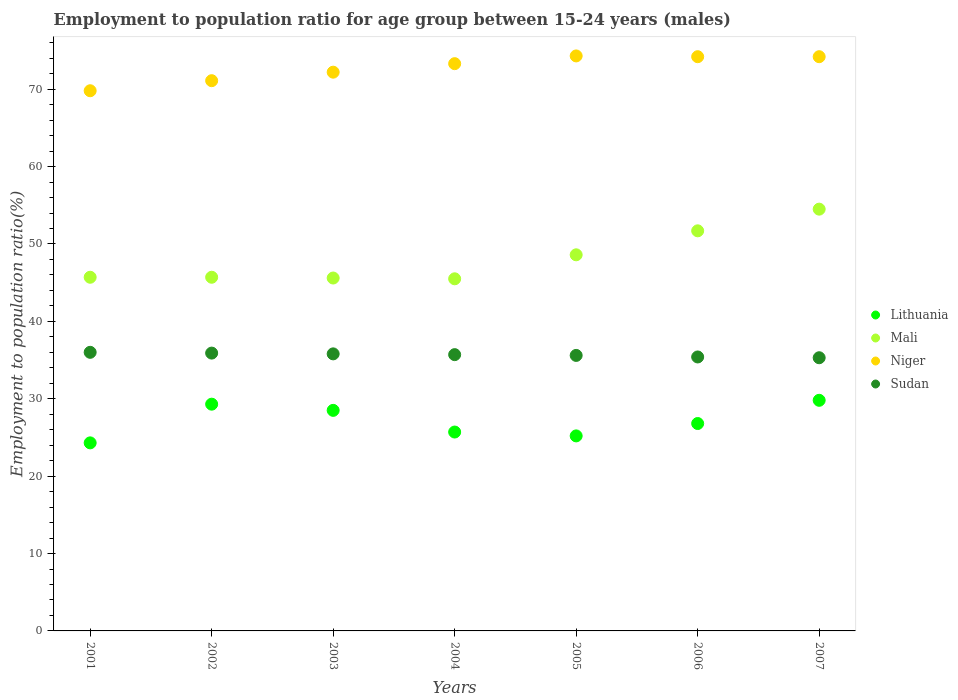What is the employment to population ratio in Niger in 2002?
Provide a short and direct response. 71.1. Across all years, what is the maximum employment to population ratio in Niger?
Ensure brevity in your answer.  74.3. Across all years, what is the minimum employment to population ratio in Sudan?
Give a very brief answer. 35.3. What is the total employment to population ratio in Niger in the graph?
Offer a terse response. 509.1. What is the difference between the employment to population ratio in Lithuania in 2003 and that in 2007?
Your response must be concise. -1.3. What is the difference between the employment to population ratio in Mali in 2006 and the employment to population ratio in Sudan in 2005?
Give a very brief answer. 16.1. What is the average employment to population ratio in Niger per year?
Provide a succinct answer. 72.73. In the year 2006, what is the difference between the employment to population ratio in Niger and employment to population ratio in Mali?
Provide a short and direct response. 22.5. What is the ratio of the employment to population ratio in Niger in 2002 to that in 2006?
Ensure brevity in your answer.  0.96. Is the employment to population ratio in Niger in 2004 less than that in 2007?
Offer a very short reply. Yes. What is the difference between the highest and the second highest employment to population ratio in Sudan?
Make the answer very short. 0.1. In how many years, is the employment to population ratio in Sudan greater than the average employment to population ratio in Sudan taken over all years?
Your answer should be very brief. 4. Is it the case that in every year, the sum of the employment to population ratio in Mali and employment to population ratio in Niger  is greater than the sum of employment to population ratio in Sudan and employment to population ratio in Lithuania?
Your response must be concise. Yes. Does the employment to population ratio in Mali monotonically increase over the years?
Your answer should be very brief. No. What is the difference between two consecutive major ticks on the Y-axis?
Give a very brief answer. 10. Are the values on the major ticks of Y-axis written in scientific E-notation?
Provide a succinct answer. No. Does the graph contain any zero values?
Provide a short and direct response. No. How many legend labels are there?
Offer a terse response. 4. How are the legend labels stacked?
Ensure brevity in your answer.  Vertical. What is the title of the graph?
Give a very brief answer. Employment to population ratio for age group between 15-24 years (males). Does "Niger" appear as one of the legend labels in the graph?
Give a very brief answer. Yes. What is the Employment to population ratio(%) in Lithuania in 2001?
Offer a very short reply. 24.3. What is the Employment to population ratio(%) in Mali in 2001?
Ensure brevity in your answer.  45.7. What is the Employment to population ratio(%) in Niger in 2001?
Your answer should be compact. 69.8. What is the Employment to population ratio(%) of Lithuania in 2002?
Provide a short and direct response. 29.3. What is the Employment to population ratio(%) in Mali in 2002?
Make the answer very short. 45.7. What is the Employment to population ratio(%) in Niger in 2002?
Offer a terse response. 71.1. What is the Employment to population ratio(%) in Sudan in 2002?
Keep it short and to the point. 35.9. What is the Employment to population ratio(%) in Mali in 2003?
Your response must be concise. 45.6. What is the Employment to population ratio(%) in Niger in 2003?
Make the answer very short. 72.2. What is the Employment to population ratio(%) of Sudan in 2003?
Your response must be concise. 35.8. What is the Employment to population ratio(%) of Lithuania in 2004?
Your answer should be compact. 25.7. What is the Employment to population ratio(%) in Mali in 2004?
Offer a very short reply. 45.5. What is the Employment to population ratio(%) in Niger in 2004?
Keep it short and to the point. 73.3. What is the Employment to population ratio(%) in Sudan in 2004?
Make the answer very short. 35.7. What is the Employment to population ratio(%) in Lithuania in 2005?
Ensure brevity in your answer.  25.2. What is the Employment to population ratio(%) of Mali in 2005?
Ensure brevity in your answer.  48.6. What is the Employment to population ratio(%) in Niger in 2005?
Provide a short and direct response. 74.3. What is the Employment to population ratio(%) in Sudan in 2005?
Your answer should be very brief. 35.6. What is the Employment to population ratio(%) of Lithuania in 2006?
Provide a short and direct response. 26.8. What is the Employment to population ratio(%) in Mali in 2006?
Provide a short and direct response. 51.7. What is the Employment to population ratio(%) of Niger in 2006?
Keep it short and to the point. 74.2. What is the Employment to population ratio(%) in Sudan in 2006?
Provide a short and direct response. 35.4. What is the Employment to population ratio(%) of Lithuania in 2007?
Ensure brevity in your answer.  29.8. What is the Employment to population ratio(%) of Mali in 2007?
Keep it short and to the point. 54.5. What is the Employment to population ratio(%) in Niger in 2007?
Ensure brevity in your answer.  74.2. What is the Employment to population ratio(%) of Sudan in 2007?
Give a very brief answer. 35.3. Across all years, what is the maximum Employment to population ratio(%) in Lithuania?
Provide a short and direct response. 29.8. Across all years, what is the maximum Employment to population ratio(%) in Mali?
Your answer should be compact. 54.5. Across all years, what is the maximum Employment to population ratio(%) in Niger?
Ensure brevity in your answer.  74.3. Across all years, what is the minimum Employment to population ratio(%) in Lithuania?
Make the answer very short. 24.3. Across all years, what is the minimum Employment to population ratio(%) in Mali?
Your answer should be compact. 45.5. Across all years, what is the minimum Employment to population ratio(%) of Niger?
Offer a very short reply. 69.8. Across all years, what is the minimum Employment to population ratio(%) of Sudan?
Keep it short and to the point. 35.3. What is the total Employment to population ratio(%) of Lithuania in the graph?
Your answer should be compact. 189.6. What is the total Employment to population ratio(%) of Mali in the graph?
Your answer should be compact. 337.3. What is the total Employment to population ratio(%) of Niger in the graph?
Give a very brief answer. 509.1. What is the total Employment to population ratio(%) in Sudan in the graph?
Offer a terse response. 249.7. What is the difference between the Employment to population ratio(%) in Lithuania in 2001 and that in 2002?
Offer a terse response. -5. What is the difference between the Employment to population ratio(%) in Sudan in 2001 and that in 2002?
Your answer should be compact. 0.1. What is the difference between the Employment to population ratio(%) of Lithuania in 2001 and that in 2003?
Ensure brevity in your answer.  -4.2. What is the difference between the Employment to population ratio(%) in Mali in 2001 and that in 2003?
Provide a succinct answer. 0.1. What is the difference between the Employment to population ratio(%) in Niger in 2001 and that in 2003?
Your answer should be compact. -2.4. What is the difference between the Employment to population ratio(%) of Sudan in 2001 and that in 2003?
Offer a terse response. 0.2. What is the difference between the Employment to population ratio(%) in Lithuania in 2001 and that in 2004?
Offer a very short reply. -1.4. What is the difference between the Employment to population ratio(%) in Niger in 2001 and that in 2004?
Make the answer very short. -3.5. What is the difference between the Employment to population ratio(%) in Sudan in 2001 and that in 2004?
Make the answer very short. 0.3. What is the difference between the Employment to population ratio(%) in Niger in 2001 and that in 2005?
Keep it short and to the point. -4.5. What is the difference between the Employment to population ratio(%) of Sudan in 2001 and that in 2005?
Make the answer very short. 0.4. What is the difference between the Employment to population ratio(%) of Lithuania in 2001 and that in 2006?
Your answer should be very brief. -2.5. What is the difference between the Employment to population ratio(%) of Mali in 2001 and that in 2006?
Your answer should be compact. -6. What is the difference between the Employment to population ratio(%) of Sudan in 2001 and that in 2006?
Offer a terse response. 0.6. What is the difference between the Employment to population ratio(%) in Mali in 2001 and that in 2007?
Your answer should be compact. -8.8. What is the difference between the Employment to population ratio(%) in Niger in 2001 and that in 2007?
Offer a very short reply. -4.4. What is the difference between the Employment to population ratio(%) of Sudan in 2002 and that in 2003?
Provide a short and direct response. 0.1. What is the difference between the Employment to population ratio(%) of Sudan in 2002 and that in 2004?
Your response must be concise. 0.2. What is the difference between the Employment to population ratio(%) of Mali in 2002 and that in 2005?
Your answer should be very brief. -2.9. What is the difference between the Employment to population ratio(%) in Sudan in 2002 and that in 2005?
Your answer should be compact. 0.3. What is the difference between the Employment to population ratio(%) of Mali in 2002 and that in 2006?
Your answer should be very brief. -6. What is the difference between the Employment to population ratio(%) of Niger in 2002 and that in 2006?
Give a very brief answer. -3.1. What is the difference between the Employment to population ratio(%) in Mali in 2002 and that in 2007?
Ensure brevity in your answer.  -8.8. What is the difference between the Employment to population ratio(%) in Lithuania in 2003 and that in 2004?
Ensure brevity in your answer.  2.8. What is the difference between the Employment to population ratio(%) of Mali in 2003 and that in 2004?
Ensure brevity in your answer.  0.1. What is the difference between the Employment to population ratio(%) of Niger in 2003 and that in 2004?
Make the answer very short. -1.1. What is the difference between the Employment to population ratio(%) in Lithuania in 2003 and that in 2005?
Ensure brevity in your answer.  3.3. What is the difference between the Employment to population ratio(%) in Mali in 2003 and that in 2005?
Keep it short and to the point. -3. What is the difference between the Employment to population ratio(%) of Sudan in 2003 and that in 2005?
Keep it short and to the point. 0.2. What is the difference between the Employment to population ratio(%) of Mali in 2003 and that in 2006?
Your answer should be very brief. -6.1. What is the difference between the Employment to population ratio(%) of Niger in 2003 and that in 2006?
Provide a short and direct response. -2. What is the difference between the Employment to population ratio(%) in Lithuania in 2003 and that in 2007?
Offer a terse response. -1.3. What is the difference between the Employment to population ratio(%) in Mali in 2003 and that in 2007?
Provide a succinct answer. -8.9. What is the difference between the Employment to population ratio(%) of Niger in 2003 and that in 2007?
Ensure brevity in your answer.  -2. What is the difference between the Employment to population ratio(%) in Sudan in 2003 and that in 2007?
Give a very brief answer. 0.5. What is the difference between the Employment to population ratio(%) of Lithuania in 2004 and that in 2005?
Provide a succinct answer. 0.5. What is the difference between the Employment to population ratio(%) in Mali in 2004 and that in 2005?
Keep it short and to the point. -3.1. What is the difference between the Employment to population ratio(%) in Lithuania in 2004 and that in 2006?
Your response must be concise. -1.1. What is the difference between the Employment to population ratio(%) of Mali in 2004 and that in 2006?
Your answer should be very brief. -6.2. What is the difference between the Employment to population ratio(%) of Sudan in 2004 and that in 2006?
Make the answer very short. 0.3. What is the difference between the Employment to population ratio(%) in Lithuania in 2004 and that in 2007?
Provide a short and direct response. -4.1. What is the difference between the Employment to population ratio(%) of Sudan in 2004 and that in 2007?
Your answer should be compact. 0.4. What is the difference between the Employment to population ratio(%) of Mali in 2005 and that in 2006?
Provide a succinct answer. -3.1. What is the difference between the Employment to population ratio(%) in Niger in 2005 and that in 2006?
Keep it short and to the point. 0.1. What is the difference between the Employment to population ratio(%) in Sudan in 2005 and that in 2006?
Ensure brevity in your answer.  0.2. What is the difference between the Employment to population ratio(%) in Lithuania in 2005 and that in 2007?
Make the answer very short. -4.6. What is the difference between the Employment to population ratio(%) of Niger in 2005 and that in 2007?
Offer a very short reply. 0.1. What is the difference between the Employment to population ratio(%) in Sudan in 2005 and that in 2007?
Give a very brief answer. 0.3. What is the difference between the Employment to population ratio(%) in Niger in 2006 and that in 2007?
Your answer should be very brief. 0. What is the difference between the Employment to population ratio(%) in Sudan in 2006 and that in 2007?
Your answer should be very brief. 0.1. What is the difference between the Employment to population ratio(%) in Lithuania in 2001 and the Employment to population ratio(%) in Mali in 2002?
Your answer should be compact. -21.4. What is the difference between the Employment to population ratio(%) of Lithuania in 2001 and the Employment to population ratio(%) of Niger in 2002?
Your answer should be compact. -46.8. What is the difference between the Employment to population ratio(%) of Lithuania in 2001 and the Employment to population ratio(%) of Sudan in 2002?
Keep it short and to the point. -11.6. What is the difference between the Employment to population ratio(%) in Mali in 2001 and the Employment to population ratio(%) in Niger in 2002?
Provide a short and direct response. -25.4. What is the difference between the Employment to population ratio(%) in Mali in 2001 and the Employment to population ratio(%) in Sudan in 2002?
Make the answer very short. 9.8. What is the difference between the Employment to population ratio(%) in Niger in 2001 and the Employment to population ratio(%) in Sudan in 2002?
Your response must be concise. 33.9. What is the difference between the Employment to population ratio(%) in Lithuania in 2001 and the Employment to population ratio(%) in Mali in 2003?
Give a very brief answer. -21.3. What is the difference between the Employment to population ratio(%) in Lithuania in 2001 and the Employment to population ratio(%) in Niger in 2003?
Provide a short and direct response. -47.9. What is the difference between the Employment to population ratio(%) of Lithuania in 2001 and the Employment to population ratio(%) of Sudan in 2003?
Make the answer very short. -11.5. What is the difference between the Employment to population ratio(%) in Mali in 2001 and the Employment to population ratio(%) in Niger in 2003?
Ensure brevity in your answer.  -26.5. What is the difference between the Employment to population ratio(%) of Mali in 2001 and the Employment to population ratio(%) of Sudan in 2003?
Offer a very short reply. 9.9. What is the difference between the Employment to population ratio(%) of Lithuania in 2001 and the Employment to population ratio(%) of Mali in 2004?
Offer a very short reply. -21.2. What is the difference between the Employment to population ratio(%) in Lithuania in 2001 and the Employment to population ratio(%) in Niger in 2004?
Provide a short and direct response. -49. What is the difference between the Employment to population ratio(%) in Lithuania in 2001 and the Employment to population ratio(%) in Sudan in 2004?
Your answer should be very brief. -11.4. What is the difference between the Employment to population ratio(%) of Mali in 2001 and the Employment to population ratio(%) of Niger in 2004?
Your answer should be very brief. -27.6. What is the difference between the Employment to population ratio(%) of Mali in 2001 and the Employment to population ratio(%) of Sudan in 2004?
Your answer should be very brief. 10. What is the difference between the Employment to population ratio(%) in Niger in 2001 and the Employment to population ratio(%) in Sudan in 2004?
Give a very brief answer. 34.1. What is the difference between the Employment to population ratio(%) of Lithuania in 2001 and the Employment to population ratio(%) of Mali in 2005?
Your answer should be compact. -24.3. What is the difference between the Employment to population ratio(%) in Lithuania in 2001 and the Employment to population ratio(%) in Sudan in 2005?
Make the answer very short. -11.3. What is the difference between the Employment to population ratio(%) of Mali in 2001 and the Employment to population ratio(%) of Niger in 2005?
Your response must be concise. -28.6. What is the difference between the Employment to population ratio(%) in Mali in 2001 and the Employment to population ratio(%) in Sudan in 2005?
Offer a terse response. 10.1. What is the difference between the Employment to population ratio(%) in Niger in 2001 and the Employment to population ratio(%) in Sudan in 2005?
Give a very brief answer. 34.2. What is the difference between the Employment to population ratio(%) of Lithuania in 2001 and the Employment to population ratio(%) of Mali in 2006?
Make the answer very short. -27.4. What is the difference between the Employment to population ratio(%) of Lithuania in 2001 and the Employment to population ratio(%) of Niger in 2006?
Provide a succinct answer. -49.9. What is the difference between the Employment to population ratio(%) in Lithuania in 2001 and the Employment to population ratio(%) in Sudan in 2006?
Provide a short and direct response. -11.1. What is the difference between the Employment to population ratio(%) of Mali in 2001 and the Employment to population ratio(%) of Niger in 2006?
Make the answer very short. -28.5. What is the difference between the Employment to population ratio(%) of Niger in 2001 and the Employment to population ratio(%) of Sudan in 2006?
Your response must be concise. 34.4. What is the difference between the Employment to population ratio(%) of Lithuania in 2001 and the Employment to population ratio(%) of Mali in 2007?
Make the answer very short. -30.2. What is the difference between the Employment to population ratio(%) in Lithuania in 2001 and the Employment to population ratio(%) in Niger in 2007?
Give a very brief answer. -49.9. What is the difference between the Employment to population ratio(%) in Mali in 2001 and the Employment to population ratio(%) in Niger in 2007?
Your answer should be compact. -28.5. What is the difference between the Employment to population ratio(%) of Niger in 2001 and the Employment to population ratio(%) of Sudan in 2007?
Offer a very short reply. 34.5. What is the difference between the Employment to population ratio(%) in Lithuania in 2002 and the Employment to population ratio(%) in Mali in 2003?
Offer a very short reply. -16.3. What is the difference between the Employment to population ratio(%) in Lithuania in 2002 and the Employment to population ratio(%) in Niger in 2003?
Your answer should be very brief. -42.9. What is the difference between the Employment to population ratio(%) of Lithuania in 2002 and the Employment to population ratio(%) of Sudan in 2003?
Keep it short and to the point. -6.5. What is the difference between the Employment to population ratio(%) in Mali in 2002 and the Employment to population ratio(%) in Niger in 2003?
Keep it short and to the point. -26.5. What is the difference between the Employment to population ratio(%) in Mali in 2002 and the Employment to population ratio(%) in Sudan in 2003?
Offer a very short reply. 9.9. What is the difference between the Employment to population ratio(%) of Niger in 2002 and the Employment to population ratio(%) of Sudan in 2003?
Make the answer very short. 35.3. What is the difference between the Employment to population ratio(%) in Lithuania in 2002 and the Employment to population ratio(%) in Mali in 2004?
Offer a very short reply. -16.2. What is the difference between the Employment to population ratio(%) in Lithuania in 2002 and the Employment to population ratio(%) in Niger in 2004?
Offer a very short reply. -44. What is the difference between the Employment to population ratio(%) in Mali in 2002 and the Employment to population ratio(%) in Niger in 2004?
Offer a terse response. -27.6. What is the difference between the Employment to population ratio(%) of Niger in 2002 and the Employment to population ratio(%) of Sudan in 2004?
Ensure brevity in your answer.  35.4. What is the difference between the Employment to population ratio(%) in Lithuania in 2002 and the Employment to population ratio(%) in Mali in 2005?
Provide a succinct answer. -19.3. What is the difference between the Employment to population ratio(%) of Lithuania in 2002 and the Employment to population ratio(%) of Niger in 2005?
Ensure brevity in your answer.  -45. What is the difference between the Employment to population ratio(%) in Lithuania in 2002 and the Employment to population ratio(%) in Sudan in 2005?
Offer a very short reply. -6.3. What is the difference between the Employment to population ratio(%) of Mali in 2002 and the Employment to population ratio(%) of Niger in 2005?
Ensure brevity in your answer.  -28.6. What is the difference between the Employment to population ratio(%) in Mali in 2002 and the Employment to population ratio(%) in Sudan in 2005?
Your answer should be compact. 10.1. What is the difference between the Employment to population ratio(%) of Niger in 2002 and the Employment to population ratio(%) of Sudan in 2005?
Make the answer very short. 35.5. What is the difference between the Employment to population ratio(%) in Lithuania in 2002 and the Employment to population ratio(%) in Mali in 2006?
Your answer should be very brief. -22.4. What is the difference between the Employment to population ratio(%) in Lithuania in 2002 and the Employment to population ratio(%) in Niger in 2006?
Give a very brief answer. -44.9. What is the difference between the Employment to population ratio(%) in Lithuania in 2002 and the Employment to population ratio(%) in Sudan in 2006?
Keep it short and to the point. -6.1. What is the difference between the Employment to population ratio(%) of Mali in 2002 and the Employment to population ratio(%) of Niger in 2006?
Offer a terse response. -28.5. What is the difference between the Employment to population ratio(%) in Niger in 2002 and the Employment to population ratio(%) in Sudan in 2006?
Your response must be concise. 35.7. What is the difference between the Employment to population ratio(%) of Lithuania in 2002 and the Employment to population ratio(%) of Mali in 2007?
Provide a succinct answer. -25.2. What is the difference between the Employment to population ratio(%) of Lithuania in 2002 and the Employment to population ratio(%) of Niger in 2007?
Your response must be concise. -44.9. What is the difference between the Employment to population ratio(%) of Lithuania in 2002 and the Employment to population ratio(%) of Sudan in 2007?
Give a very brief answer. -6. What is the difference between the Employment to population ratio(%) of Mali in 2002 and the Employment to population ratio(%) of Niger in 2007?
Ensure brevity in your answer.  -28.5. What is the difference between the Employment to population ratio(%) of Mali in 2002 and the Employment to population ratio(%) of Sudan in 2007?
Offer a terse response. 10.4. What is the difference between the Employment to population ratio(%) in Niger in 2002 and the Employment to population ratio(%) in Sudan in 2007?
Make the answer very short. 35.8. What is the difference between the Employment to population ratio(%) of Lithuania in 2003 and the Employment to population ratio(%) of Niger in 2004?
Offer a very short reply. -44.8. What is the difference between the Employment to population ratio(%) in Lithuania in 2003 and the Employment to population ratio(%) in Sudan in 2004?
Make the answer very short. -7.2. What is the difference between the Employment to population ratio(%) in Mali in 2003 and the Employment to population ratio(%) in Niger in 2004?
Keep it short and to the point. -27.7. What is the difference between the Employment to population ratio(%) in Niger in 2003 and the Employment to population ratio(%) in Sudan in 2004?
Offer a very short reply. 36.5. What is the difference between the Employment to population ratio(%) of Lithuania in 2003 and the Employment to population ratio(%) of Mali in 2005?
Provide a short and direct response. -20.1. What is the difference between the Employment to population ratio(%) in Lithuania in 2003 and the Employment to population ratio(%) in Niger in 2005?
Your response must be concise. -45.8. What is the difference between the Employment to population ratio(%) in Lithuania in 2003 and the Employment to population ratio(%) in Sudan in 2005?
Your answer should be compact. -7.1. What is the difference between the Employment to population ratio(%) of Mali in 2003 and the Employment to population ratio(%) of Niger in 2005?
Provide a succinct answer. -28.7. What is the difference between the Employment to population ratio(%) in Mali in 2003 and the Employment to population ratio(%) in Sudan in 2005?
Provide a succinct answer. 10. What is the difference between the Employment to population ratio(%) of Niger in 2003 and the Employment to population ratio(%) of Sudan in 2005?
Keep it short and to the point. 36.6. What is the difference between the Employment to population ratio(%) of Lithuania in 2003 and the Employment to population ratio(%) of Mali in 2006?
Offer a very short reply. -23.2. What is the difference between the Employment to population ratio(%) in Lithuania in 2003 and the Employment to population ratio(%) in Niger in 2006?
Provide a short and direct response. -45.7. What is the difference between the Employment to population ratio(%) in Mali in 2003 and the Employment to population ratio(%) in Niger in 2006?
Your response must be concise. -28.6. What is the difference between the Employment to population ratio(%) in Niger in 2003 and the Employment to population ratio(%) in Sudan in 2006?
Your answer should be compact. 36.8. What is the difference between the Employment to population ratio(%) in Lithuania in 2003 and the Employment to population ratio(%) in Mali in 2007?
Give a very brief answer. -26. What is the difference between the Employment to population ratio(%) in Lithuania in 2003 and the Employment to population ratio(%) in Niger in 2007?
Offer a very short reply. -45.7. What is the difference between the Employment to population ratio(%) of Lithuania in 2003 and the Employment to population ratio(%) of Sudan in 2007?
Offer a terse response. -6.8. What is the difference between the Employment to population ratio(%) of Mali in 2003 and the Employment to population ratio(%) of Niger in 2007?
Offer a very short reply. -28.6. What is the difference between the Employment to population ratio(%) of Niger in 2003 and the Employment to population ratio(%) of Sudan in 2007?
Your answer should be compact. 36.9. What is the difference between the Employment to population ratio(%) in Lithuania in 2004 and the Employment to population ratio(%) in Mali in 2005?
Give a very brief answer. -22.9. What is the difference between the Employment to population ratio(%) of Lithuania in 2004 and the Employment to population ratio(%) of Niger in 2005?
Keep it short and to the point. -48.6. What is the difference between the Employment to population ratio(%) in Mali in 2004 and the Employment to population ratio(%) in Niger in 2005?
Your answer should be compact. -28.8. What is the difference between the Employment to population ratio(%) of Mali in 2004 and the Employment to population ratio(%) of Sudan in 2005?
Offer a very short reply. 9.9. What is the difference between the Employment to population ratio(%) of Niger in 2004 and the Employment to population ratio(%) of Sudan in 2005?
Ensure brevity in your answer.  37.7. What is the difference between the Employment to population ratio(%) in Lithuania in 2004 and the Employment to population ratio(%) in Mali in 2006?
Offer a terse response. -26. What is the difference between the Employment to population ratio(%) of Lithuania in 2004 and the Employment to population ratio(%) of Niger in 2006?
Ensure brevity in your answer.  -48.5. What is the difference between the Employment to population ratio(%) in Mali in 2004 and the Employment to population ratio(%) in Niger in 2006?
Provide a succinct answer. -28.7. What is the difference between the Employment to population ratio(%) of Niger in 2004 and the Employment to population ratio(%) of Sudan in 2006?
Your answer should be compact. 37.9. What is the difference between the Employment to population ratio(%) of Lithuania in 2004 and the Employment to population ratio(%) of Mali in 2007?
Give a very brief answer. -28.8. What is the difference between the Employment to population ratio(%) in Lithuania in 2004 and the Employment to population ratio(%) in Niger in 2007?
Give a very brief answer. -48.5. What is the difference between the Employment to population ratio(%) in Lithuania in 2004 and the Employment to population ratio(%) in Sudan in 2007?
Provide a succinct answer. -9.6. What is the difference between the Employment to population ratio(%) in Mali in 2004 and the Employment to population ratio(%) in Niger in 2007?
Ensure brevity in your answer.  -28.7. What is the difference between the Employment to population ratio(%) of Mali in 2004 and the Employment to population ratio(%) of Sudan in 2007?
Your answer should be very brief. 10.2. What is the difference between the Employment to population ratio(%) of Niger in 2004 and the Employment to population ratio(%) of Sudan in 2007?
Give a very brief answer. 38. What is the difference between the Employment to population ratio(%) in Lithuania in 2005 and the Employment to population ratio(%) in Mali in 2006?
Give a very brief answer. -26.5. What is the difference between the Employment to population ratio(%) in Lithuania in 2005 and the Employment to population ratio(%) in Niger in 2006?
Keep it short and to the point. -49. What is the difference between the Employment to population ratio(%) of Mali in 2005 and the Employment to population ratio(%) of Niger in 2006?
Provide a succinct answer. -25.6. What is the difference between the Employment to population ratio(%) in Niger in 2005 and the Employment to population ratio(%) in Sudan in 2006?
Give a very brief answer. 38.9. What is the difference between the Employment to population ratio(%) in Lithuania in 2005 and the Employment to population ratio(%) in Mali in 2007?
Your answer should be compact. -29.3. What is the difference between the Employment to population ratio(%) of Lithuania in 2005 and the Employment to population ratio(%) of Niger in 2007?
Your answer should be very brief. -49. What is the difference between the Employment to population ratio(%) of Mali in 2005 and the Employment to population ratio(%) of Niger in 2007?
Offer a terse response. -25.6. What is the difference between the Employment to population ratio(%) in Mali in 2005 and the Employment to population ratio(%) in Sudan in 2007?
Offer a very short reply. 13.3. What is the difference between the Employment to population ratio(%) in Lithuania in 2006 and the Employment to population ratio(%) in Mali in 2007?
Give a very brief answer. -27.7. What is the difference between the Employment to population ratio(%) in Lithuania in 2006 and the Employment to population ratio(%) in Niger in 2007?
Make the answer very short. -47.4. What is the difference between the Employment to population ratio(%) of Lithuania in 2006 and the Employment to population ratio(%) of Sudan in 2007?
Offer a terse response. -8.5. What is the difference between the Employment to population ratio(%) of Mali in 2006 and the Employment to population ratio(%) of Niger in 2007?
Offer a terse response. -22.5. What is the difference between the Employment to population ratio(%) of Niger in 2006 and the Employment to population ratio(%) of Sudan in 2007?
Your answer should be very brief. 38.9. What is the average Employment to population ratio(%) in Lithuania per year?
Your response must be concise. 27.09. What is the average Employment to population ratio(%) in Mali per year?
Your answer should be very brief. 48.19. What is the average Employment to population ratio(%) in Niger per year?
Your answer should be compact. 72.73. What is the average Employment to population ratio(%) in Sudan per year?
Your response must be concise. 35.67. In the year 2001, what is the difference between the Employment to population ratio(%) of Lithuania and Employment to population ratio(%) of Mali?
Make the answer very short. -21.4. In the year 2001, what is the difference between the Employment to population ratio(%) of Lithuania and Employment to population ratio(%) of Niger?
Your response must be concise. -45.5. In the year 2001, what is the difference between the Employment to population ratio(%) of Mali and Employment to population ratio(%) of Niger?
Your answer should be compact. -24.1. In the year 2001, what is the difference between the Employment to population ratio(%) in Niger and Employment to population ratio(%) in Sudan?
Make the answer very short. 33.8. In the year 2002, what is the difference between the Employment to population ratio(%) of Lithuania and Employment to population ratio(%) of Mali?
Provide a short and direct response. -16.4. In the year 2002, what is the difference between the Employment to population ratio(%) in Lithuania and Employment to population ratio(%) in Niger?
Your response must be concise. -41.8. In the year 2002, what is the difference between the Employment to population ratio(%) of Lithuania and Employment to population ratio(%) of Sudan?
Provide a short and direct response. -6.6. In the year 2002, what is the difference between the Employment to population ratio(%) in Mali and Employment to population ratio(%) in Niger?
Give a very brief answer. -25.4. In the year 2002, what is the difference between the Employment to population ratio(%) of Mali and Employment to population ratio(%) of Sudan?
Your response must be concise. 9.8. In the year 2002, what is the difference between the Employment to population ratio(%) in Niger and Employment to population ratio(%) in Sudan?
Offer a terse response. 35.2. In the year 2003, what is the difference between the Employment to population ratio(%) of Lithuania and Employment to population ratio(%) of Mali?
Ensure brevity in your answer.  -17.1. In the year 2003, what is the difference between the Employment to population ratio(%) in Lithuania and Employment to population ratio(%) in Niger?
Offer a terse response. -43.7. In the year 2003, what is the difference between the Employment to population ratio(%) in Lithuania and Employment to population ratio(%) in Sudan?
Your response must be concise. -7.3. In the year 2003, what is the difference between the Employment to population ratio(%) in Mali and Employment to population ratio(%) in Niger?
Your response must be concise. -26.6. In the year 2003, what is the difference between the Employment to population ratio(%) of Niger and Employment to population ratio(%) of Sudan?
Your answer should be compact. 36.4. In the year 2004, what is the difference between the Employment to population ratio(%) of Lithuania and Employment to population ratio(%) of Mali?
Make the answer very short. -19.8. In the year 2004, what is the difference between the Employment to population ratio(%) of Lithuania and Employment to population ratio(%) of Niger?
Your answer should be compact. -47.6. In the year 2004, what is the difference between the Employment to population ratio(%) of Lithuania and Employment to population ratio(%) of Sudan?
Provide a succinct answer. -10. In the year 2004, what is the difference between the Employment to population ratio(%) of Mali and Employment to population ratio(%) of Niger?
Give a very brief answer. -27.8. In the year 2004, what is the difference between the Employment to population ratio(%) in Niger and Employment to population ratio(%) in Sudan?
Provide a succinct answer. 37.6. In the year 2005, what is the difference between the Employment to population ratio(%) of Lithuania and Employment to population ratio(%) of Mali?
Ensure brevity in your answer.  -23.4. In the year 2005, what is the difference between the Employment to population ratio(%) of Lithuania and Employment to population ratio(%) of Niger?
Your answer should be very brief. -49.1. In the year 2005, what is the difference between the Employment to population ratio(%) in Lithuania and Employment to population ratio(%) in Sudan?
Provide a short and direct response. -10.4. In the year 2005, what is the difference between the Employment to population ratio(%) of Mali and Employment to population ratio(%) of Niger?
Give a very brief answer. -25.7. In the year 2005, what is the difference between the Employment to population ratio(%) in Niger and Employment to population ratio(%) in Sudan?
Ensure brevity in your answer.  38.7. In the year 2006, what is the difference between the Employment to population ratio(%) in Lithuania and Employment to population ratio(%) in Mali?
Offer a terse response. -24.9. In the year 2006, what is the difference between the Employment to population ratio(%) in Lithuania and Employment to population ratio(%) in Niger?
Your answer should be very brief. -47.4. In the year 2006, what is the difference between the Employment to population ratio(%) of Lithuania and Employment to population ratio(%) of Sudan?
Provide a short and direct response. -8.6. In the year 2006, what is the difference between the Employment to population ratio(%) of Mali and Employment to population ratio(%) of Niger?
Ensure brevity in your answer.  -22.5. In the year 2006, what is the difference between the Employment to population ratio(%) of Mali and Employment to population ratio(%) of Sudan?
Offer a terse response. 16.3. In the year 2006, what is the difference between the Employment to population ratio(%) in Niger and Employment to population ratio(%) in Sudan?
Give a very brief answer. 38.8. In the year 2007, what is the difference between the Employment to population ratio(%) in Lithuania and Employment to population ratio(%) in Mali?
Give a very brief answer. -24.7. In the year 2007, what is the difference between the Employment to population ratio(%) of Lithuania and Employment to population ratio(%) of Niger?
Provide a succinct answer. -44.4. In the year 2007, what is the difference between the Employment to population ratio(%) in Mali and Employment to population ratio(%) in Niger?
Offer a terse response. -19.7. In the year 2007, what is the difference between the Employment to population ratio(%) of Mali and Employment to population ratio(%) of Sudan?
Provide a short and direct response. 19.2. In the year 2007, what is the difference between the Employment to population ratio(%) of Niger and Employment to population ratio(%) of Sudan?
Provide a succinct answer. 38.9. What is the ratio of the Employment to population ratio(%) in Lithuania in 2001 to that in 2002?
Give a very brief answer. 0.83. What is the ratio of the Employment to population ratio(%) of Mali in 2001 to that in 2002?
Offer a very short reply. 1. What is the ratio of the Employment to population ratio(%) in Niger in 2001 to that in 2002?
Your response must be concise. 0.98. What is the ratio of the Employment to population ratio(%) of Sudan in 2001 to that in 2002?
Keep it short and to the point. 1. What is the ratio of the Employment to population ratio(%) in Lithuania in 2001 to that in 2003?
Your answer should be compact. 0.85. What is the ratio of the Employment to population ratio(%) of Mali in 2001 to that in 2003?
Offer a very short reply. 1. What is the ratio of the Employment to population ratio(%) of Niger in 2001 to that in 2003?
Offer a terse response. 0.97. What is the ratio of the Employment to population ratio(%) of Sudan in 2001 to that in 2003?
Your answer should be very brief. 1.01. What is the ratio of the Employment to population ratio(%) of Lithuania in 2001 to that in 2004?
Offer a terse response. 0.95. What is the ratio of the Employment to population ratio(%) of Mali in 2001 to that in 2004?
Give a very brief answer. 1. What is the ratio of the Employment to population ratio(%) of Niger in 2001 to that in 2004?
Your response must be concise. 0.95. What is the ratio of the Employment to population ratio(%) of Sudan in 2001 to that in 2004?
Give a very brief answer. 1.01. What is the ratio of the Employment to population ratio(%) in Mali in 2001 to that in 2005?
Your response must be concise. 0.94. What is the ratio of the Employment to population ratio(%) of Niger in 2001 to that in 2005?
Offer a very short reply. 0.94. What is the ratio of the Employment to population ratio(%) in Sudan in 2001 to that in 2005?
Give a very brief answer. 1.01. What is the ratio of the Employment to population ratio(%) of Lithuania in 2001 to that in 2006?
Make the answer very short. 0.91. What is the ratio of the Employment to population ratio(%) in Mali in 2001 to that in 2006?
Ensure brevity in your answer.  0.88. What is the ratio of the Employment to population ratio(%) of Niger in 2001 to that in 2006?
Ensure brevity in your answer.  0.94. What is the ratio of the Employment to population ratio(%) in Sudan in 2001 to that in 2006?
Provide a succinct answer. 1.02. What is the ratio of the Employment to population ratio(%) of Lithuania in 2001 to that in 2007?
Ensure brevity in your answer.  0.82. What is the ratio of the Employment to population ratio(%) in Mali in 2001 to that in 2007?
Provide a short and direct response. 0.84. What is the ratio of the Employment to population ratio(%) in Niger in 2001 to that in 2007?
Provide a short and direct response. 0.94. What is the ratio of the Employment to population ratio(%) of Sudan in 2001 to that in 2007?
Give a very brief answer. 1.02. What is the ratio of the Employment to population ratio(%) of Lithuania in 2002 to that in 2003?
Ensure brevity in your answer.  1.03. What is the ratio of the Employment to population ratio(%) of Mali in 2002 to that in 2003?
Ensure brevity in your answer.  1. What is the ratio of the Employment to population ratio(%) of Lithuania in 2002 to that in 2004?
Provide a succinct answer. 1.14. What is the ratio of the Employment to population ratio(%) of Mali in 2002 to that in 2004?
Offer a very short reply. 1. What is the ratio of the Employment to population ratio(%) of Niger in 2002 to that in 2004?
Keep it short and to the point. 0.97. What is the ratio of the Employment to population ratio(%) in Sudan in 2002 to that in 2004?
Make the answer very short. 1.01. What is the ratio of the Employment to population ratio(%) of Lithuania in 2002 to that in 2005?
Provide a short and direct response. 1.16. What is the ratio of the Employment to population ratio(%) of Mali in 2002 to that in 2005?
Offer a terse response. 0.94. What is the ratio of the Employment to population ratio(%) in Niger in 2002 to that in 2005?
Provide a succinct answer. 0.96. What is the ratio of the Employment to population ratio(%) of Sudan in 2002 to that in 2005?
Make the answer very short. 1.01. What is the ratio of the Employment to population ratio(%) of Lithuania in 2002 to that in 2006?
Keep it short and to the point. 1.09. What is the ratio of the Employment to population ratio(%) in Mali in 2002 to that in 2006?
Provide a short and direct response. 0.88. What is the ratio of the Employment to population ratio(%) in Niger in 2002 to that in 2006?
Your answer should be very brief. 0.96. What is the ratio of the Employment to population ratio(%) of Sudan in 2002 to that in 2006?
Offer a very short reply. 1.01. What is the ratio of the Employment to population ratio(%) in Lithuania in 2002 to that in 2007?
Your answer should be compact. 0.98. What is the ratio of the Employment to population ratio(%) in Mali in 2002 to that in 2007?
Keep it short and to the point. 0.84. What is the ratio of the Employment to population ratio(%) of Niger in 2002 to that in 2007?
Ensure brevity in your answer.  0.96. What is the ratio of the Employment to population ratio(%) in Sudan in 2002 to that in 2007?
Ensure brevity in your answer.  1.02. What is the ratio of the Employment to population ratio(%) in Lithuania in 2003 to that in 2004?
Your response must be concise. 1.11. What is the ratio of the Employment to population ratio(%) of Mali in 2003 to that in 2004?
Provide a short and direct response. 1. What is the ratio of the Employment to population ratio(%) of Niger in 2003 to that in 2004?
Provide a succinct answer. 0.98. What is the ratio of the Employment to population ratio(%) of Lithuania in 2003 to that in 2005?
Your answer should be compact. 1.13. What is the ratio of the Employment to population ratio(%) in Mali in 2003 to that in 2005?
Provide a succinct answer. 0.94. What is the ratio of the Employment to population ratio(%) in Niger in 2003 to that in 2005?
Your answer should be very brief. 0.97. What is the ratio of the Employment to population ratio(%) in Sudan in 2003 to that in 2005?
Your answer should be compact. 1.01. What is the ratio of the Employment to population ratio(%) of Lithuania in 2003 to that in 2006?
Give a very brief answer. 1.06. What is the ratio of the Employment to population ratio(%) of Mali in 2003 to that in 2006?
Provide a succinct answer. 0.88. What is the ratio of the Employment to population ratio(%) in Sudan in 2003 to that in 2006?
Provide a short and direct response. 1.01. What is the ratio of the Employment to population ratio(%) of Lithuania in 2003 to that in 2007?
Give a very brief answer. 0.96. What is the ratio of the Employment to population ratio(%) in Mali in 2003 to that in 2007?
Provide a short and direct response. 0.84. What is the ratio of the Employment to population ratio(%) in Sudan in 2003 to that in 2007?
Give a very brief answer. 1.01. What is the ratio of the Employment to population ratio(%) in Lithuania in 2004 to that in 2005?
Provide a short and direct response. 1.02. What is the ratio of the Employment to population ratio(%) in Mali in 2004 to that in 2005?
Give a very brief answer. 0.94. What is the ratio of the Employment to population ratio(%) of Niger in 2004 to that in 2005?
Your response must be concise. 0.99. What is the ratio of the Employment to population ratio(%) of Sudan in 2004 to that in 2005?
Offer a very short reply. 1. What is the ratio of the Employment to population ratio(%) in Lithuania in 2004 to that in 2006?
Make the answer very short. 0.96. What is the ratio of the Employment to population ratio(%) in Mali in 2004 to that in 2006?
Your answer should be compact. 0.88. What is the ratio of the Employment to population ratio(%) in Niger in 2004 to that in 2006?
Offer a terse response. 0.99. What is the ratio of the Employment to population ratio(%) in Sudan in 2004 to that in 2006?
Ensure brevity in your answer.  1.01. What is the ratio of the Employment to population ratio(%) of Lithuania in 2004 to that in 2007?
Your response must be concise. 0.86. What is the ratio of the Employment to population ratio(%) in Mali in 2004 to that in 2007?
Offer a very short reply. 0.83. What is the ratio of the Employment to population ratio(%) of Niger in 2004 to that in 2007?
Offer a very short reply. 0.99. What is the ratio of the Employment to population ratio(%) in Sudan in 2004 to that in 2007?
Offer a very short reply. 1.01. What is the ratio of the Employment to population ratio(%) of Lithuania in 2005 to that in 2006?
Provide a short and direct response. 0.94. What is the ratio of the Employment to population ratio(%) in Niger in 2005 to that in 2006?
Your answer should be very brief. 1. What is the ratio of the Employment to population ratio(%) in Sudan in 2005 to that in 2006?
Keep it short and to the point. 1.01. What is the ratio of the Employment to population ratio(%) in Lithuania in 2005 to that in 2007?
Offer a very short reply. 0.85. What is the ratio of the Employment to population ratio(%) in Mali in 2005 to that in 2007?
Your response must be concise. 0.89. What is the ratio of the Employment to population ratio(%) in Sudan in 2005 to that in 2007?
Ensure brevity in your answer.  1.01. What is the ratio of the Employment to population ratio(%) of Lithuania in 2006 to that in 2007?
Offer a terse response. 0.9. What is the ratio of the Employment to population ratio(%) of Mali in 2006 to that in 2007?
Provide a succinct answer. 0.95. What is the ratio of the Employment to population ratio(%) of Sudan in 2006 to that in 2007?
Make the answer very short. 1. What is the difference between the highest and the second highest Employment to population ratio(%) of Lithuania?
Ensure brevity in your answer.  0.5. What is the difference between the highest and the second highest Employment to population ratio(%) of Sudan?
Ensure brevity in your answer.  0.1. What is the difference between the highest and the lowest Employment to population ratio(%) in Mali?
Provide a succinct answer. 9. What is the difference between the highest and the lowest Employment to population ratio(%) of Sudan?
Ensure brevity in your answer.  0.7. 